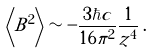<formula> <loc_0><loc_0><loc_500><loc_500>\left \langle B ^ { 2 } \right \rangle \sim - \frac { 3 \hbar { c } } { 1 6 \pi ^ { 2 } } \frac { 1 } { z ^ { 4 } } \, .</formula> 